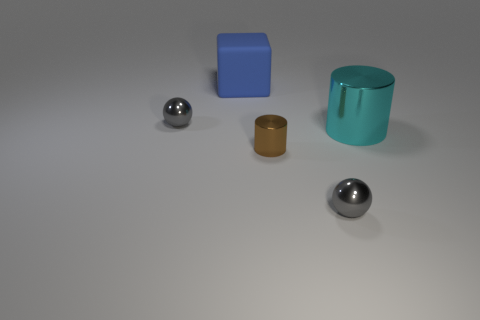Add 1 gray spheres. How many objects exist? 6 Subtract all cubes. How many objects are left? 4 Add 1 big red cylinders. How many big red cylinders exist? 1 Subtract 0 brown blocks. How many objects are left? 5 Subtract all blue matte cubes. Subtract all green rubber cylinders. How many objects are left? 4 Add 5 rubber things. How many rubber things are left? 6 